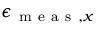Convert formula to latex. <formula><loc_0><loc_0><loc_500><loc_500>\epsilon _ { m e a s , x }</formula> 